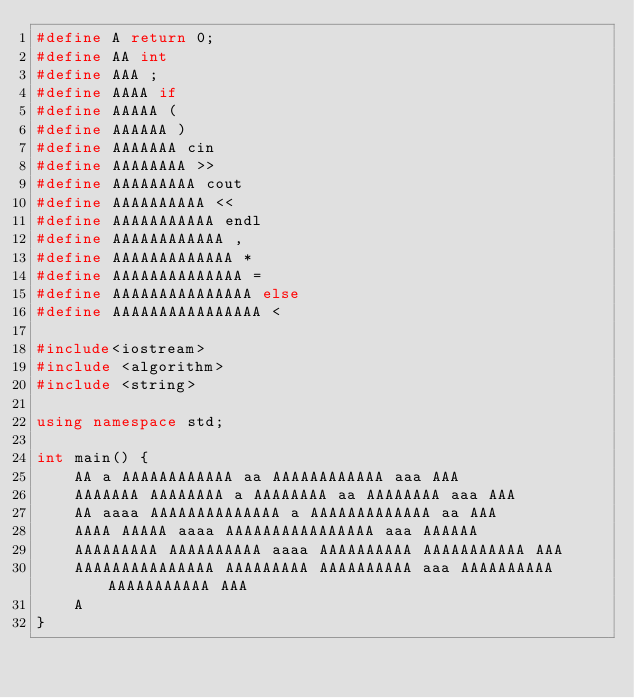<code> <loc_0><loc_0><loc_500><loc_500><_C++_>#define A return 0;
#define AA int
#define AAA ;
#define AAAA if
#define AAAAA (
#define AAAAAA )
#define AAAAAAA cin
#define AAAAAAAA >>
#define AAAAAAAAA cout
#define AAAAAAAAAA <<
#define AAAAAAAAAAA endl
#define AAAAAAAAAAAA ,
#define AAAAAAAAAAAAA *
#define AAAAAAAAAAAAAA =
#define AAAAAAAAAAAAAAA else
#define AAAAAAAAAAAAAAAA <

#include<iostream>
#include <algorithm>
#include <string>

using namespace std;

int main() {
	AA a AAAAAAAAAAAA aa AAAAAAAAAAAA aaa AAA
	AAAAAAA AAAAAAAA a AAAAAAAA aa AAAAAAAA aaa AAA
	AA aaaa AAAAAAAAAAAAAA a AAAAAAAAAAAAA aa AAA
	AAAA AAAAA aaaa AAAAAAAAAAAAAAAA aaa AAAAAA
	AAAAAAAAA AAAAAAAAAA aaaa AAAAAAAAAA AAAAAAAAAAA AAA
	AAAAAAAAAAAAAAA AAAAAAAAA AAAAAAAAAA aaa AAAAAAAAAA AAAAAAAAAAA AAA
	A
}</code> 